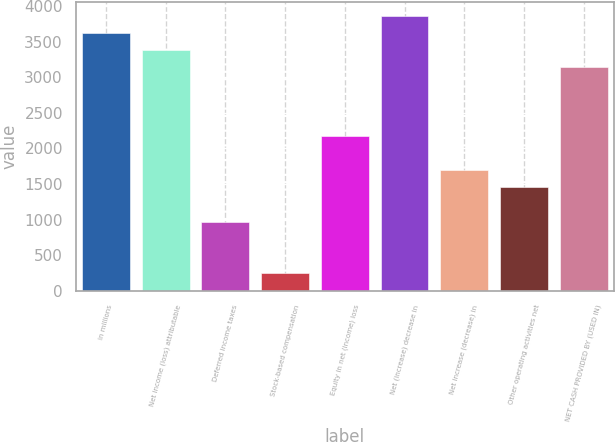<chart> <loc_0><loc_0><loc_500><loc_500><bar_chart><fcel>in millions<fcel>Net income (loss) attributable<fcel>Deferred income taxes<fcel>Stock-based compensation<fcel>Equity in net (income) loss<fcel>Net (increase) decrease in<fcel>Net increase (decrease) in<fcel>Other operating activities net<fcel>NET CASH PROVIDED BY (USED IN)<nl><fcel>3625<fcel>3383.6<fcel>969.6<fcel>245.4<fcel>2176.6<fcel>3866.4<fcel>1693.8<fcel>1452.4<fcel>3142.2<nl></chart> 